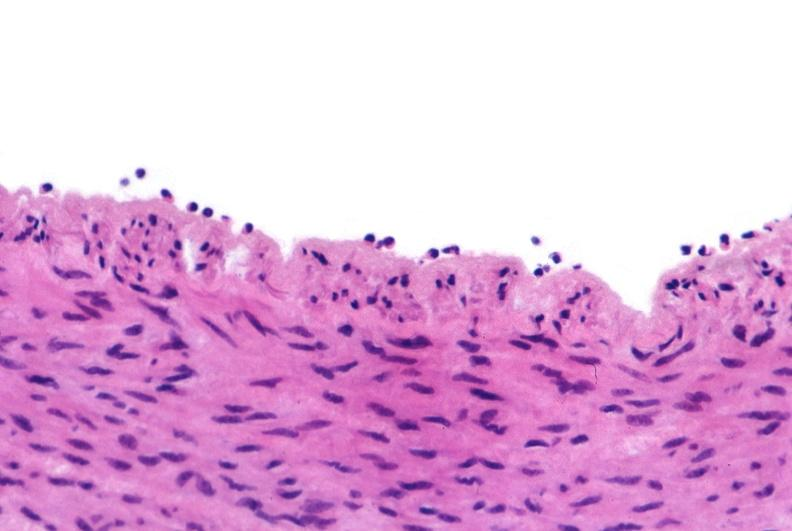s breast present?
Answer the question using a single word or phrase. No 